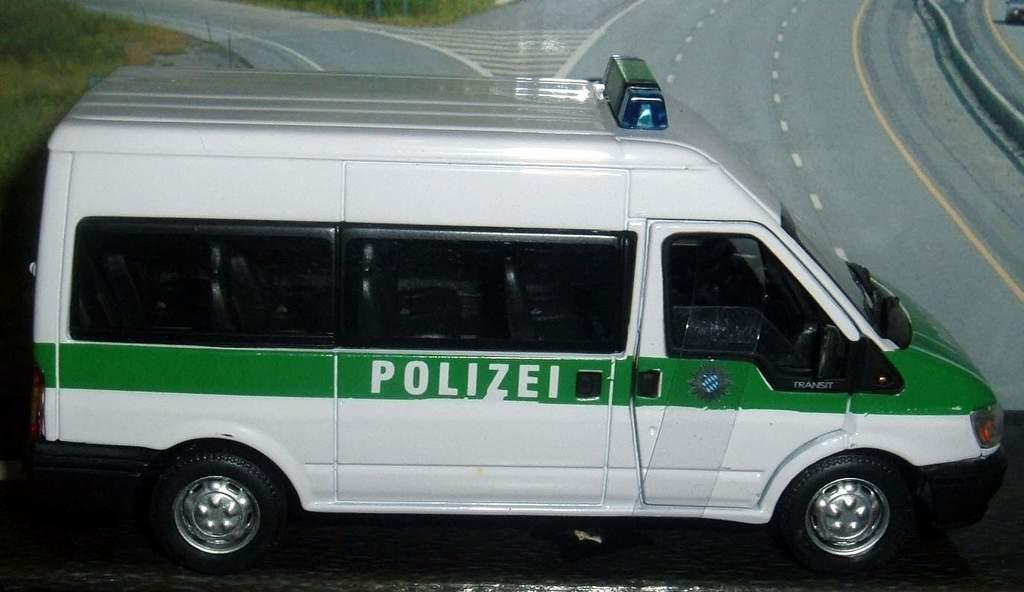What is the main subject in the center of the image? There is a vehicle in the center of the image. What can be seen in the background of the image? There is a road and grass in the background of the image. Are there any other objects or structures visible in the background? Yes, there are rods in the background of the image. What is the board-like object at the bottom of the image? There is a board-like object at the bottom of the image, but its purpose or function is not clear from the provided facts. What type of farm animals can be seen grazing on the grass in the image? There are no farm animals visible in the image; it only features a vehicle, a road, grass, and rods in the background. What cast member from a popular TV show is driving the vehicle in the image? There is no information about the driver of the vehicle in the image, nor is there any reference to a TV show or cast member. 